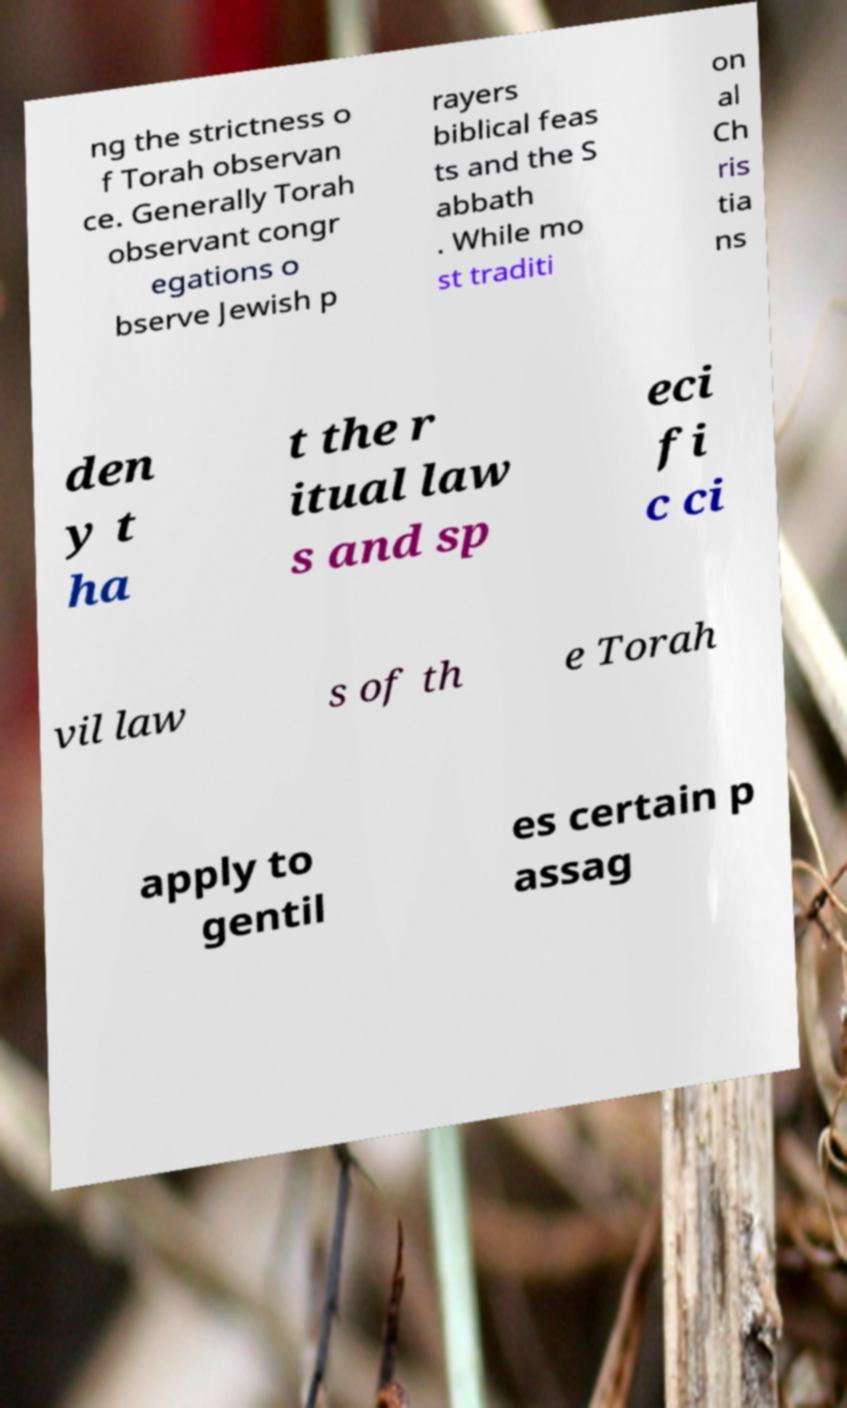I need the written content from this picture converted into text. Can you do that? ng the strictness o f Torah observan ce. Generally Torah observant congr egations o bserve Jewish p rayers biblical feas ts and the S abbath . While mo st traditi on al Ch ris tia ns den y t ha t the r itual law s and sp eci fi c ci vil law s of th e Torah apply to gentil es certain p assag 